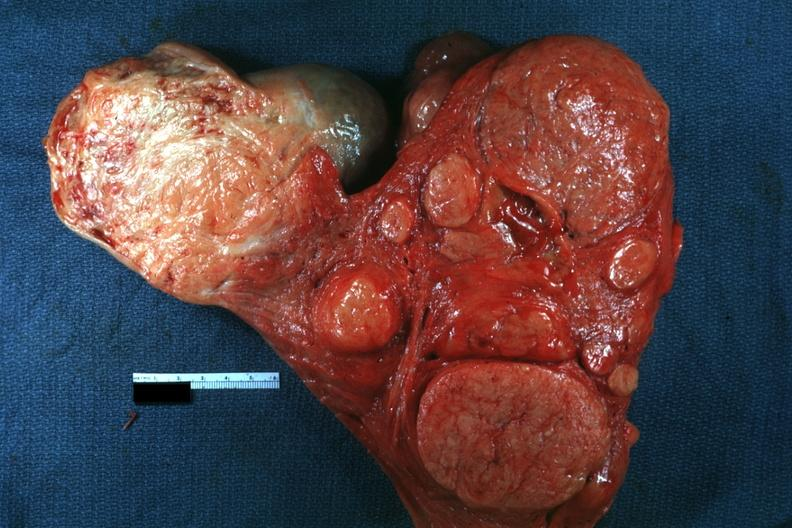what is present?
Answer the question using a single word or phrase. Uterus 